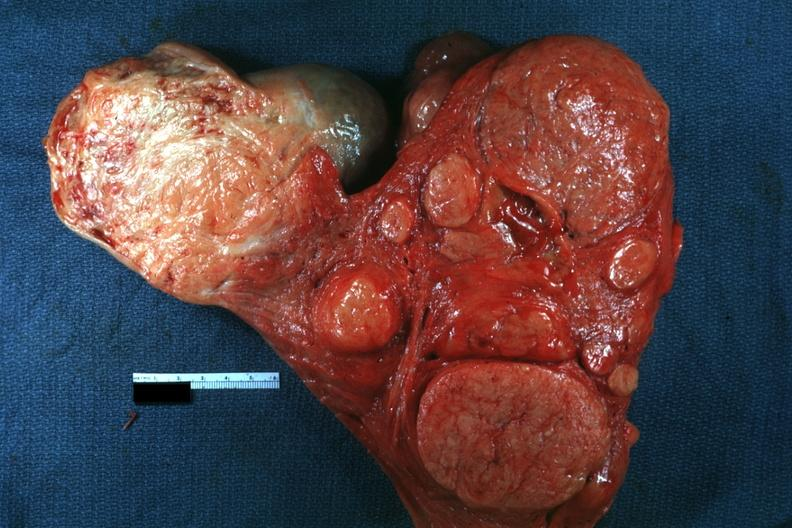what is present?
Answer the question using a single word or phrase. Uterus 